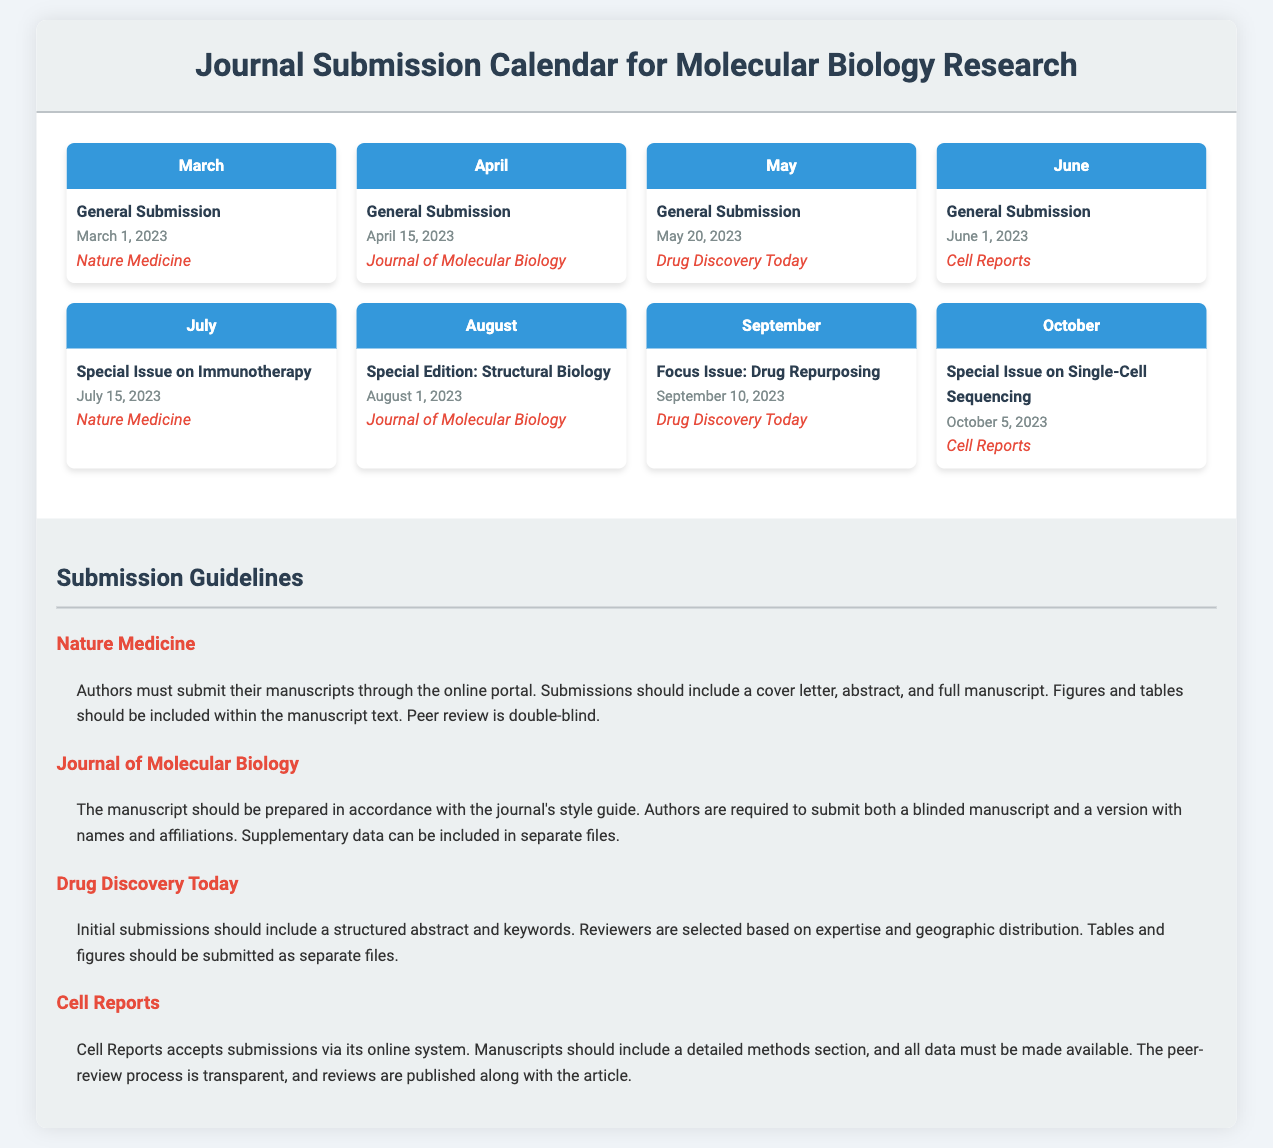What is the first submission date for Nature Medicine? The first submission date for Nature Medicine is March 1, 2023.
Answer: March 1, 2023 What special issue is due in July? The special issue due in July is on Immunotherapy.
Answer: Immunotherapy What is required for submissions to Drug Discovery Today? Drug Discovery Today requires a structured abstract and keywords for initial submissions.
Answer: Structured abstract and keywords Which journal has a submission date on October 5, 2023? The journal with a submission date on October 5, 2023 is Cell Reports.
Answer: Cell Reports How many months have submission deadlines in 2023 according to the calendar? There are eight months with submission deadlines in 2023 according to the calendar.
Answer: Eight What submission format is required for the Journal of Molecular Biology? The submission format required for the Journal of Molecular Biology includes both a blinded manuscript and a version with names and affiliations.
Answer: Blinded manuscript and a version with names and affiliations Which journal states that peer review is double-blind? Nature Medicine states that peer review is double-blind.
Answer: Nature Medicine What is the common theme for the September issue of Drug Discovery Today? The common theme for the September issue of Drug Discovery Today is Drug Repurposing.
Answer: Drug Repurposing 